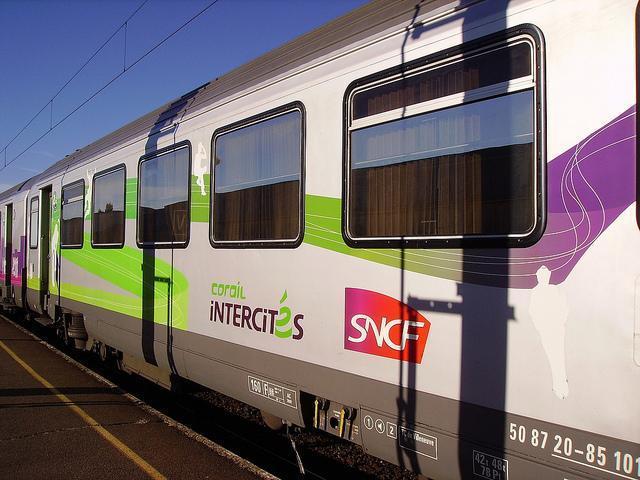How many train windows are visible?
Give a very brief answer. 6. How many chairs are visible?
Give a very brief answer. 0. 